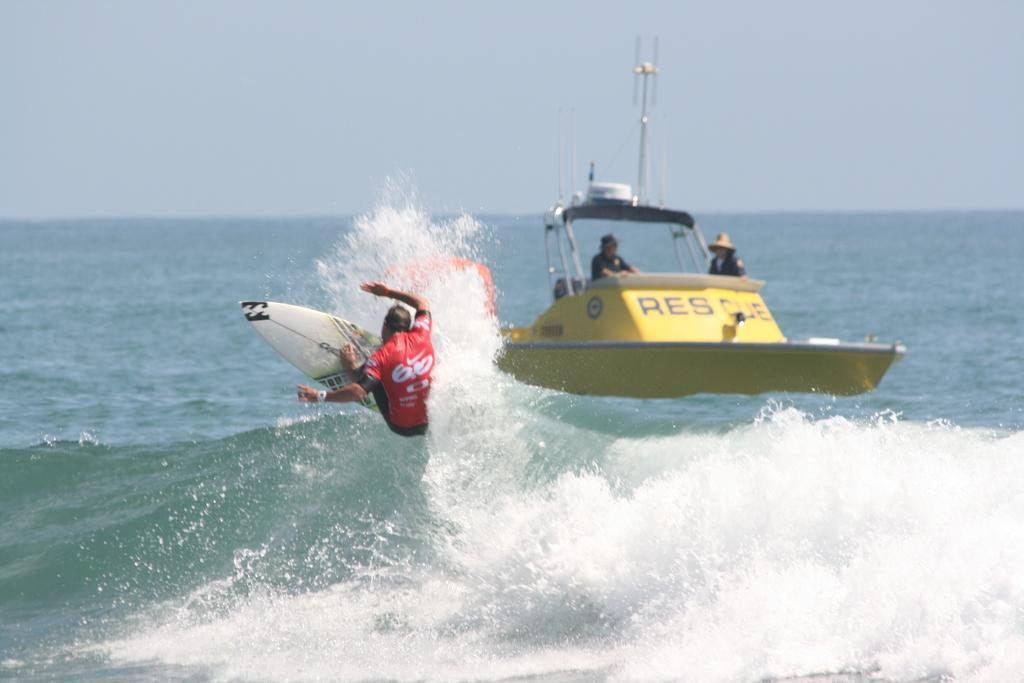<image>
Provide a brief description of the given image. A windsurfer catching a wave in front of a yellow rescue boat. 